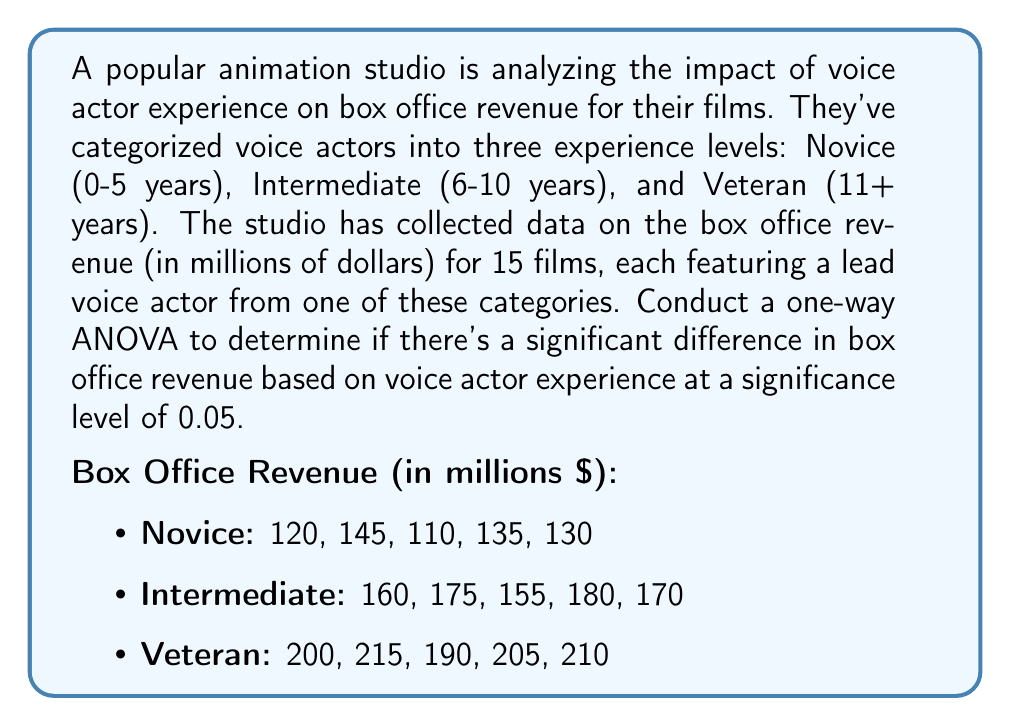Could you help me with this problem? Let's approach this step-by-step:

1. State the hypotheses:
   $H_0$: There is no significant difference in mean box office revenue among the three voice actor experience levels.
   $H_1$: There is a significant difference in mean box office revenue among the three voice actor experience levels.

2. Calculate the sum of squares:

   a. Total Sum of Squares (SST):
      $$SST = \sum_{i=1}^{n} (x_i - \bar{x})^2$$
      where $x_i$ are individual observations and $\bar{x}$ is the grand mean.

   b. Between-group Sum of Squares (SSB):
      $$SSB = \sum_{i=1}^{k} n_i(\bar{x_i} - \bar{x})^2$$
      where $k$ is the number of groups, $n_i$ is the size of each group, and $\bar{x_i}$ is the mean of each group.

   c. Within-group Sum of Squares (SSW):
      $$SSW = SST - SSB$$

3. Calculate degrees of freedom:
   - Total df = n - 1 = 15 - 1 = 14
   - Between-group df = k - 1 = 3 - 1 = 2
   - Within-group df = n - k = 15 - 3 = 12

4. Calculate Mean Square values:
   $$MS_B = \frac{SSB}{df_B}$$
   $$MS_W = \frac{SSW}{df_W}$$

5. Calculate F-statistic:
   $$F = \frac{MS_B}{MS_W}$$

6. Find the critical F-value:
   $F_{crit} = F_{0.05, 2, 12}$ (from F-distribution table)

7. Compare F-statistic with F-critical:
   If F > F-critical, reject the null hypothesis.

Calculations:
Grand Mean = 166.67
SST = 29,166.67
SSB = 26,666.67
SSW = 2,500

MS_B = 13,333.33
MS_W = 208.33

F = 64

F-critical (0.05, 2, 12) ≈ 3.89

Since 64 > 3.89, we reject the null hypothesis.
Answer: Reject the null hypothesis. There is a significant difference in mean box office revenue among the three voice actor experience levels (F(2,12) = 64, p < 0.05). 